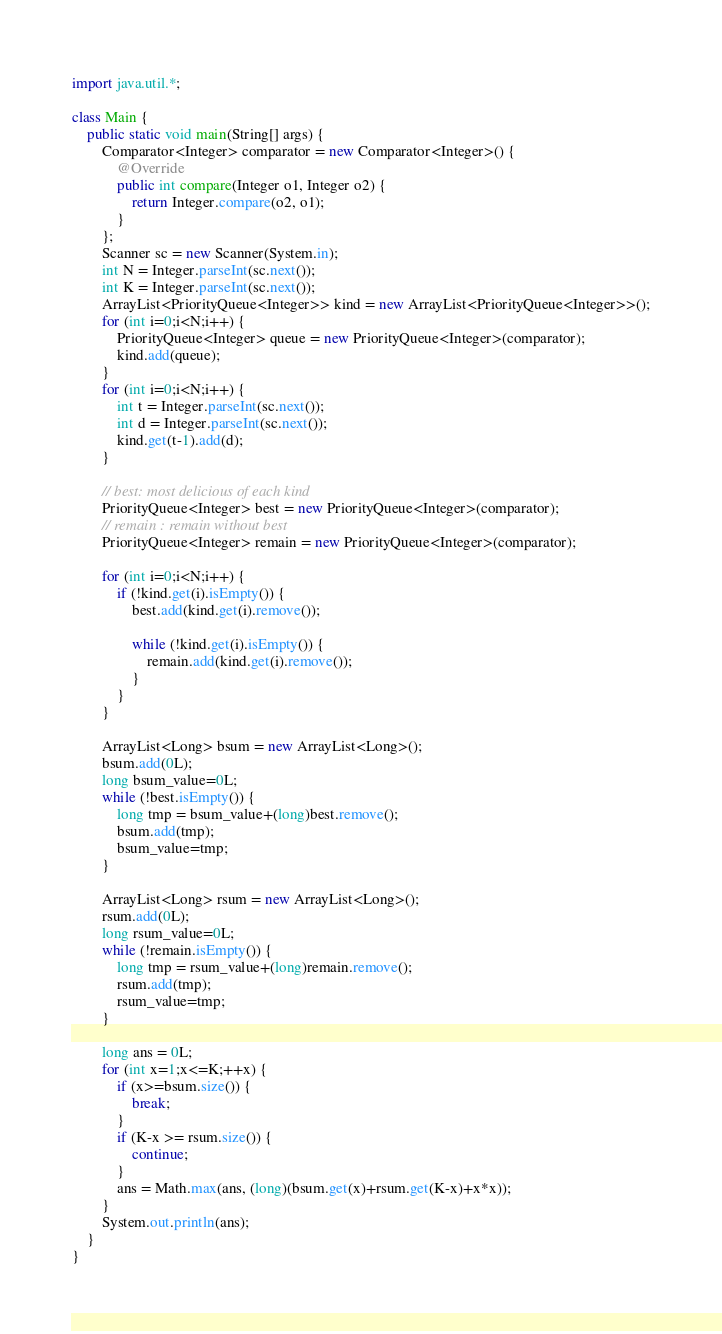Convert code to text. <code><loc_0><loc_0><loc_500><loc_500><_Java_>import java.util.*;

class Main {
	public static void main(String[] args) {
		Comparator<Integer> comparator = new Comparator<Integer>() {
		    @Override
		    public int compare(Integer o1, Integer o2) {
		        return Integer.compare(o2, o1);
		    }
		};
		Scanner sc = new Scanner(System.in);
		int N = Integer.parseInt(sc.next());
		int K = Integer.parseInt(sc.next());
		ArrayList<PriorityQueue<Integer>> kind = new ArrayList<PriorityQueue<Integer>>();
		for (int i=0;i<N;i++) {
			PriorityQueue<Integer> queue = new PriorityQueue<Integer>(comparator);
			kind.add(queue);
		}
		for (int i=0;i<N;i++) {
			int t = Integer.parseInt(sc.next());
			int d = Integer.parseInt(sc.next());
			kind.get(t-1).add(d);
		}

		// best: most delicious of each kind
		PriorityQueue<Integer> best = new PriorityQueue<Integer>(comparator);
		// remain : remain without best
		PriorityQueue<Integer> remain = new PriorityQueue<Integer>(comparator);

		for (int i=0;i<N;i++) {
			if (!kind.get(i).isEmpty()) {
				best.add(kind.get(i).remove());

				while (!kind.get(i).isEmpty()) {
					remain.add(kind.get(i).remove());
				}
			}
		}

		ArrayList<Long> bsum = new ArrayList<Long>();
		bsum.add(0L);
		long bsum_value=0L;
		while (!best.isEmpty()) {
			long tmp = bsum_value+(long)best.remove();
			bsum.add(tmp);
			bsum_value=tmp;
		}

		ArrayList<Long> rsum = new ArrayList<Long>();
		rsum.add(0L);
		long rsum_value=0L;
		while (!remain.isEmpty()) {
			long tmp = rsum_value+(long)remain.remove();
			rsum.add(tmp);
			rsum_value=tmp;
		}

		long ans = 0L;
		for (int x=1;x<=K;++x) {
			if (x>=bsum.size()) {
				break;
			}
			if (K-x >= rsum.size()) {
				continue;
			}
			ans = Math.max(ans, (long)(bsum.get(x)+rsum.get(K-x)+x*x));
		}
		System.out.println(ans);
	}
}</code> 